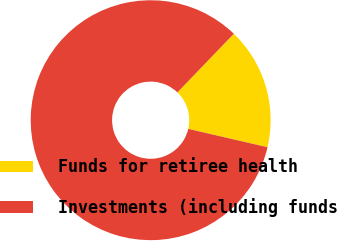Convert chart to OTSL. <chart><loc_0><loc_0><loc_500><loc_500><pie_chart><fcel>Funds for retiree health<fcel>Investments (including funds<nl><fcel>16.43%<fcel>83.57%<nl></chart> 